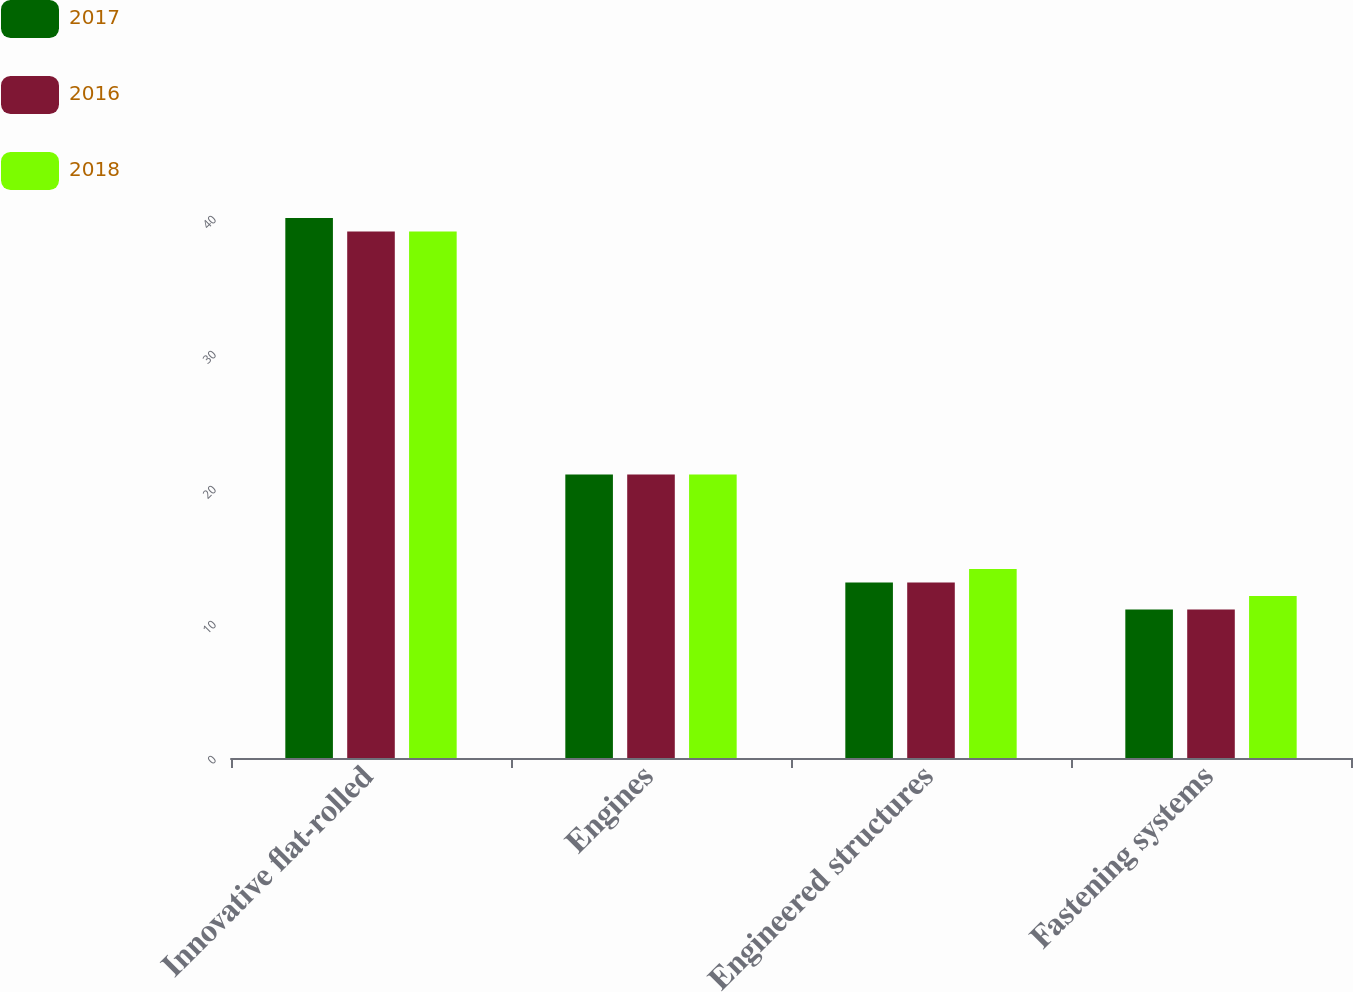Convert chart. <chart><loc_0><loc_0><loc_500><loc_500><stacked_bar_chart><ecel><fcel>Innovative flat-rolled<fcel>Engines<fcel>Engineered structures<fcel>Fastening systems<nl><fcel>2017<fcel>40<fcel>21<fcel>13<fcel>11<nl><fcel>2016<fcel>39<fcel>21<fcel>13<fcel>11<nl><fcel>2018<fcel>39<fcel>21<fcel>14<fcel>12<nl></chart> 